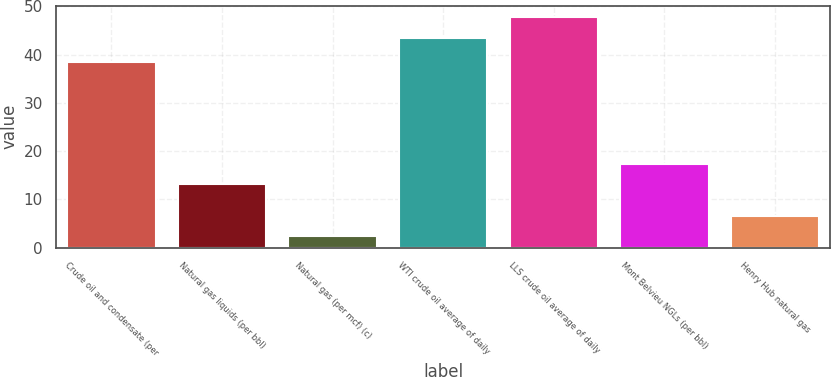<chart> <loc_0><loc_0><loc_500><loc_500><bar_chart><fcel>Crude oil and condensate (per<fcel>Natural gas liquids (per bbl)<fcel>Natural gas (per mcf) (c)<fcel>WTI crude oil average of daily<fcel>LLS crude oil average of daily<fcel>Mont Belvieu NGLs (per bbl)<fcel>Henry Hub natural gas<nl><fcel>38.57<fcel>13.15<fcel>2.38<fcel>43.47<fcel>47.73<fcel>17.41<fcel>6.64<nl></chart> 